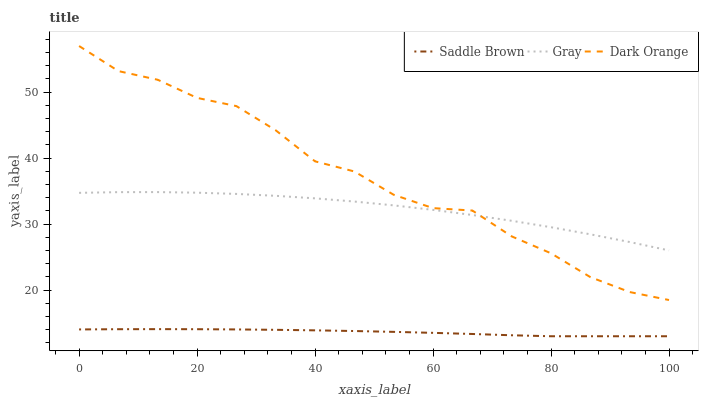Does Saddle Brown have the minimum area under the curve?
Answer yes or no. Yes. Does Dark Orange have the maximum area under the curve?
Answer yes or no. Yes. Does Dark Orange have the minimum area under the curve?
Answer yes or no. No. Does Saddle Brown have the maximum area under the curve?
Answer yes or no. No. Is Saddle Brown the smoothest?
Answer yes or no. Yes. Is Dark Orange the roughest?
Answer yes or no. Yes. Is Dark Orange the smoothest?
Answer yes or no. No. Is Saddle Brown the roughest?
Answer yes or no. No. Does Saddle Brown have the lowest value?
Answer yes or no. Yes. Does Dark Orange have the lowest value?
Answer yes or no. No. Does Dark Orange have the highest value?
Answer yes or no. Yes. Does Saddle Brown have the highest value?
Answer yes or no. No. Is Saddle Brown less than Gray?
Answer yes or no. Yes. Is Dark Orange greater than Saddle Brown?
Answer yes or no. Yes. Does Dark Orange intersect Gray?
Answer yes or no. Yes. Is Dark Orange less than Gray?
Answer yes or no. No. Is Dark Orange greater than Gray?
Answer yes or no. No. Does Saddle Brown intersect Gray?
Answer yes or no. No. 